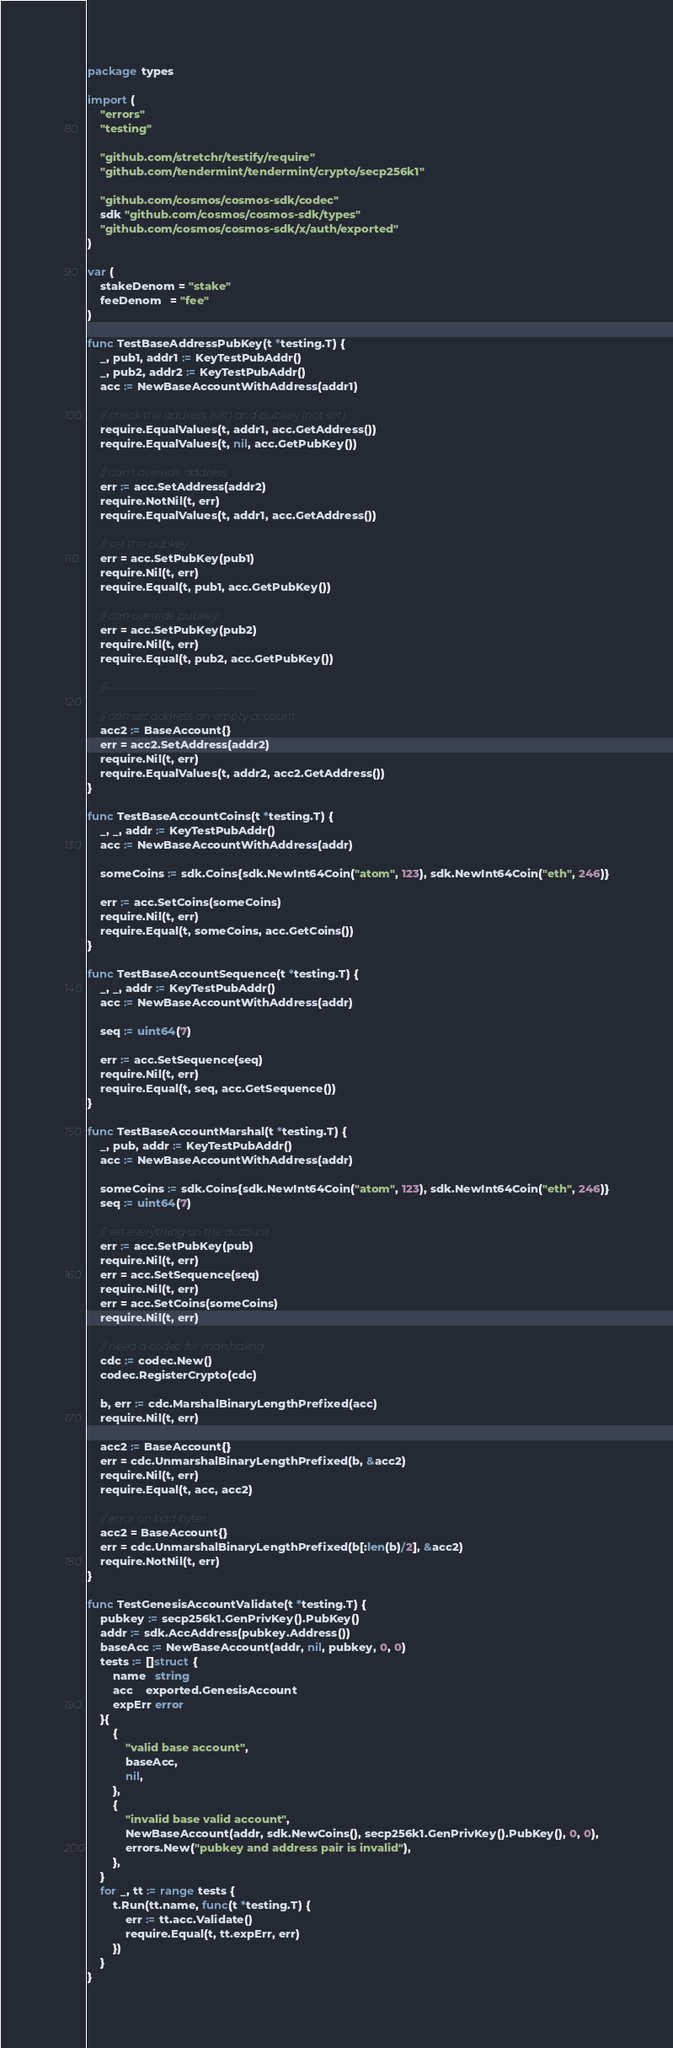Convert code to text. <code><loc_0><loc_0><loc_500><loc_500><_Go_>package types

import (
	"errors"
	"testing"

	"github.com/stretchr/testify/require"
	"github.com/tendermint/tendermint/crypto/secp256k1"

	"github.com/cosmos/cosmos-sdk/codec"
	sdk "github.com/cosmos/cosmos-sdk/types"
	"github.com/cosmos/cosmos-sdk/x/auth/exported"
)

var (
	stakeDenom = "stake"
	feeDenom   = "fee"
)

func TestBaseAddressPubKey(t *testing.T) {
	_, pub1, addr1 := KeyTestPubAddr()
	_, pub2, addr2 := KeyTestPubAddr()
	acc := NewBaseAccountWithAddress(addr1)

	// check the address (set) and pubkey (not set)
	require.EqualValues(t, addr1, acc.GetAddress())
	require.EqualValues(t, nil, acc.GetPubKey())

	// can't override address
	err := acc.SetAddress(addr2)
	require.NotNil(t, err)
	require.EqualValues(t, addr1, acc.GetAddress())

	// set the pubkey
	err = acc.SetPubKey(pub1)
	require.Nil(t, err)
	require.Equal(t, pub1, acc.GetPubKey())

	// can override pubkey
	err = acc.SetPubKey(pub2)
	require.Nil(t, err)
	require.Equal(t, pub2, acc.GetPubKey())

	//------------------------------------

	// can set address on empty account
	acc2 := BaseAccount{}
	err = acc2.SetAddress(addr2)
	require.Nil(t, err)
	require.EqualValues(t, addr2, acc2.GetAddress())
}

func TestBaseAccountCoins(t *testing.T) {
	_, _, addr := KeyTestPubAddr()
	acc := NewBaseAccountWithAddress(addr)

	someCoins := sdk.Coins{sdk.NewInt64Coin("atom", 123), sdk.NewInt64Coin("eth", 246)}

	err := acc.SetCoins(someCoins)
	require.Nil(t, err)
	require.Equal(t, someCoins, acc.GetCoins())
}

func TestBaseAccountSequence(t *testing.T) {
	_, _, addr := KeyTestPubAddr()
	acc := NewBaseAccountWithAddress(addr)

	seq := uint64(7)

	err := acc.SetSequence(seq)
	require.Nil(t, err)
	require.Equal(t, seq, acc.GetSequence())
}

func TestBaseAccountMarshal(t *testing.T) {
	_, pub, addr := KeyTestPubAddr()
	acc := NewBaseAccountWithAddress(addr)

	someCoins := sdk.Coins{sdk.NewInt64Coin("atom", 123), sdk.NewInt64Coin("eth", 246)}
	seq := uint64(7)

	// set everything on the account
	err := acc.SetPubKey(pub)
	require.Nil(t, err)
	err = acc.SetSequence(seq)
	require.Nil(t, err)
	err = acc.SetCoins(someCoins)
	require.Nil(t, err)

	// need a codec for marshaling
	cdc := codec.New()
	codec.RegisterCrypto(cdc)

	b, err := cdc.MarshalBinaryLengthPrefixed(acc)
	require.Nil(t, err)

	acc2 := BaseAccount{}
	err = cdc.UnmarshalBinaryLengthPrefixed(b, &acc2)
	require.Nil(t, err)
	require.Equal(t, acc, acc2)

	// error on bad bytes
	acc2 = BaseAccount{}
	err = cdc.UnmarshalBinaryLengthPrefixed(b[:len(b)/2], &acc2)
	require.NotNil(t, err)
}

func TestGenesisAccountValidate(t *testing.T) {
	pubkey := secp256k1.GenPrivKey().PubKey()
	addr := sdk.AccAddress(pubkey.Address())
	baseAcc := NewBaseAccount(addr, nil, pubkey, 0, 0)
	tests := []struct {
		name   string
		acc    exported.GenesisAccount
		expErr error
	}{
		{
			"valid base account",
			baseAcc,
			nil,
		},
		{
			"invalid base valid account",
			NewBaseAccount(addr, sdk.NewCoins(), secp256k1.GenPrivKey().PubKey(), 0, 0),
			errors.New("pubkey and address pair is invalid"),
		},
	}
	for _, tt := range tests {
		t.Run(tt.name, func(t *testing.T) {
			err := tt.acc.Validate()
			require.Equal(t, tt.expErr, err)
		})
	}
}
</code> 